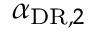<formula> <loc_0><loc_0><loc_500><loc_500>\alpha _ { D R , 2 }</formula> 